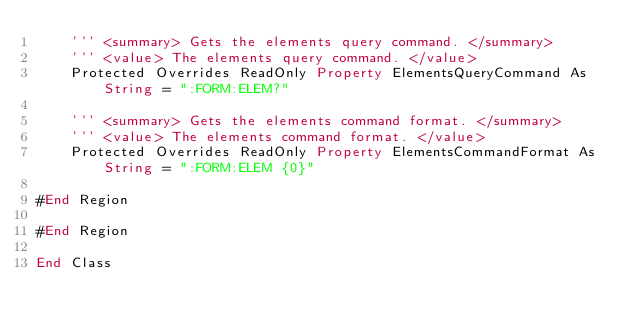Convert code to text. <code><loc_0><loc_0><loc_500><loc_500><_VisualBasic_>    ''' <summary> Gets the elements query command. </summary>
    ''' <value> The elements query command. </value>
    Protected Overrides ReadOnly Property ElementsQueryCommand As String = ":FORM:ELEM?"

    ''' <summary> Gets the elements command format. </summary>
    ''' <value> The elements command format. </value>
    Protected Overrides ReadOnly Property ElementsCommandFormat As String = ":FORM:ELEM {0}"

#End Region

#End Region

End Class
</code> 